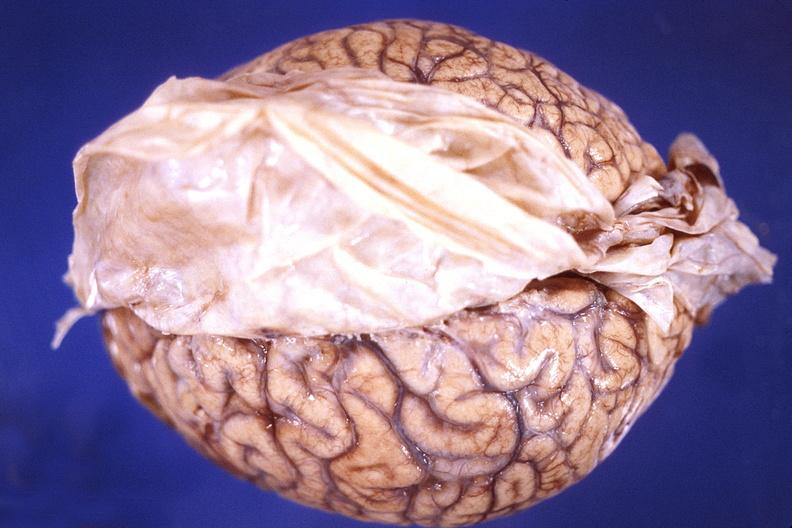does this image show brain, cryptococcal meningitis?
Answer the question using a single word or phrase. Yes 